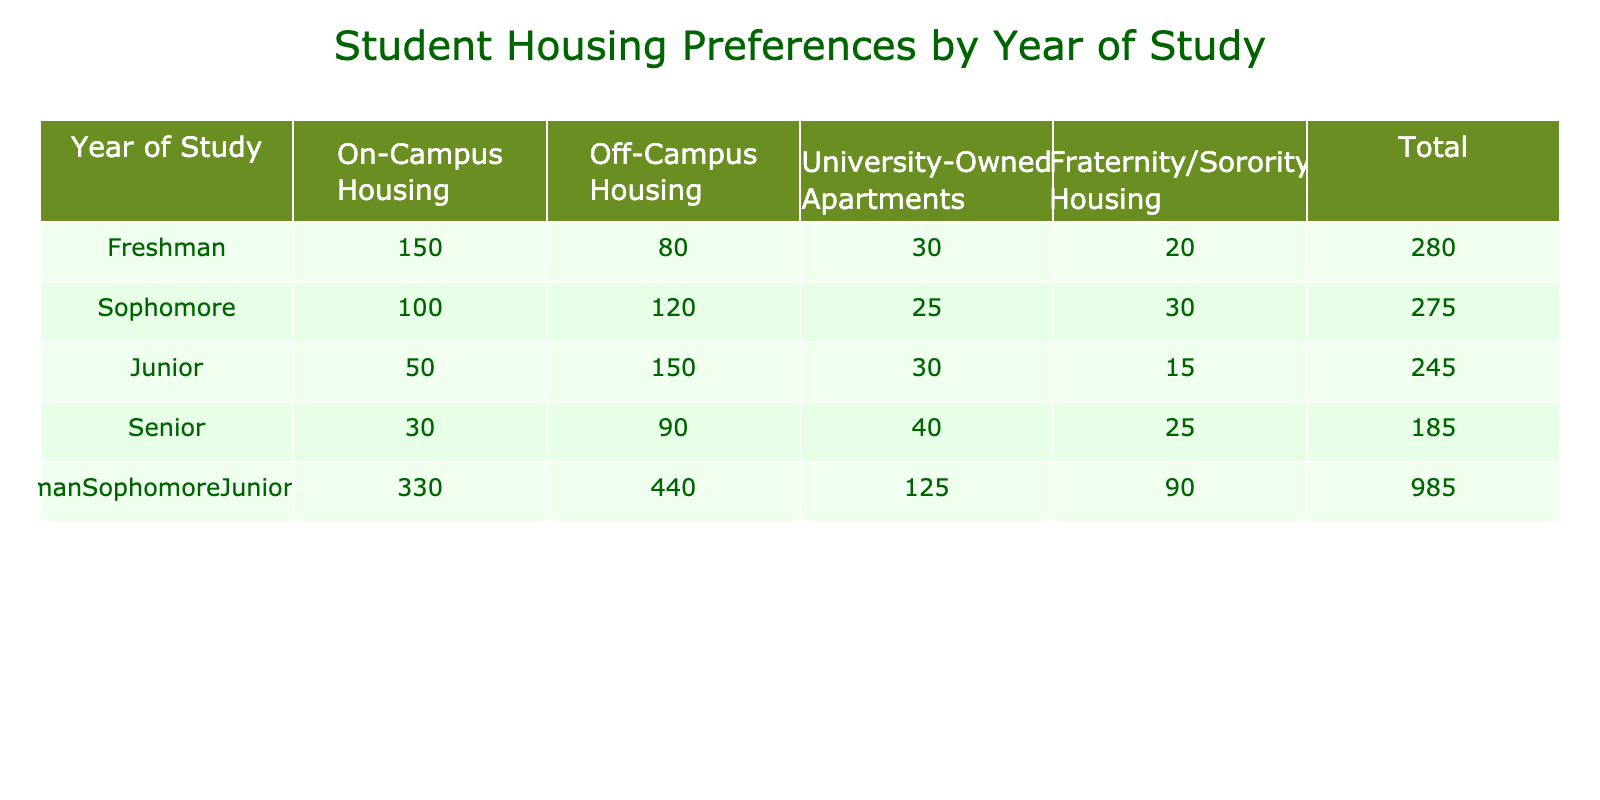What is the total number of freshmen living in on-campus housing? According to the table, the number of freshmen living in on-campus housing is directly stated under the "On-Campus Housing" column for the "Freshman" row, which shows 150.
Answer: 150 Which year of study has the highest preference for off-campus housing? Looking at the "Off-Campus Housing" column, the values are 80 for Freshmen, 120 for Sophomores, 150 for Juniors, and 90 for Seniors. The highest value is 150, which corresponds to Juniors.
Answer: Juniors What is the combined total number of students living in University-Owned Apartments across all years? To find this, sum the values of University-Owned Apartments for all years: 30 (Freshman) + 25 (Sophomore) + 30 (Junior) + 40 (Senior) = 125.
Answer: 125 Do more Senior students live in Fraternity/Sorority housing than Freshmen? The table shows 20 Freshmen living in Fraternity/Sorority housing and 25 Seniors. Since 25 is greater than 20, the answer is yes.
Answer: Yes What is the average number of students living in on-campus housing across all years of study? The total number of students living in on-campus housing is: 150 (Freshman) + 100 (Sophomore) + 50 (Junior) + 30 (Senior) = 330. There are 4 years of study, so the average is 330/4 = 82.5.
Answer: 82.5 For which housing preference do Sophomore students have the lowest number of residents? The table shows the following numbers for Sophomores: On-Campus (100), Off-Campus (120), University-Owned Apartments (25), and Fraternity/Sorority (30). The lowest number is for University-Owned Apartments at 25.
Answer: University-Owned Apartments How many total students prefer living in on-campus housing and in University-Owned Apartments combined? The total for on-campus housing is 150 (Freshman) + 100 (Sophomore) + 50 (Junior) + 30 (Senior) = 330. For University-Owned Apartments, the total is 30 + 25 + 30 + 40 = 125. The combined total is 330 + 125 = 455.
Answer: 455 Is it true that Junior students prefer on-campus housing over Fraternity/Sorority housing? The table shows that 50 Juniors live in on-campus housing, and 15 in Fraternity/Sorority housing. Since 50 is greater than 15, the statement is true.
Answer: True 